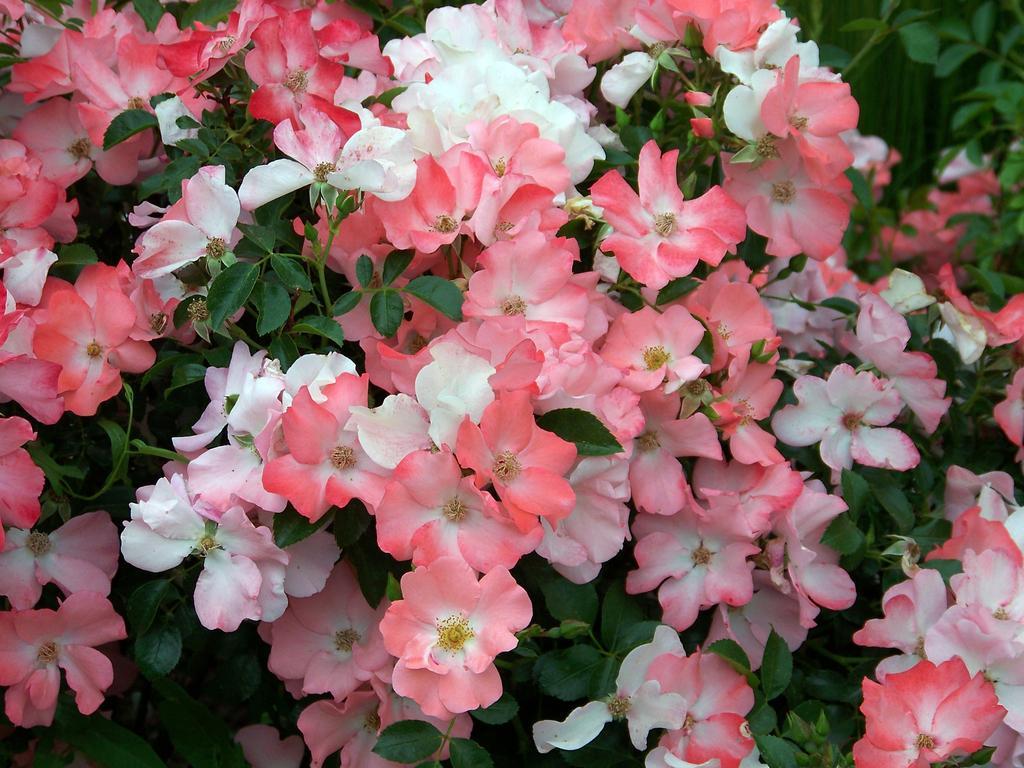Could you give a brief overview of what you see in this image? In the image there are beautiful pink and white flowers to the plants. 